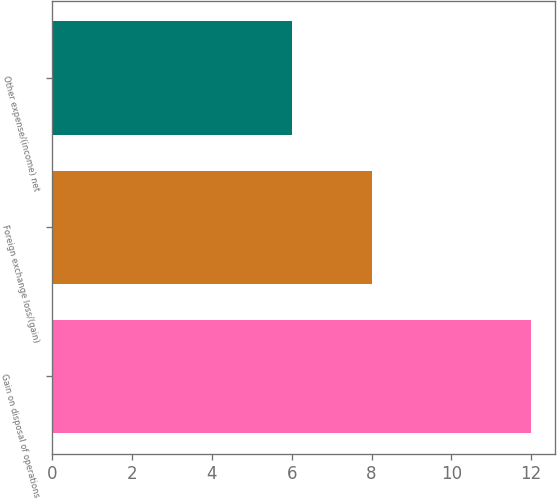Convert chart. <chart><loc_0><loc_0><loc_500><loc_500><bar_chart><fcel>Gain on disposal of operations<fcel>Foreign exchange loss/(gain)<fcel>Other expense/(income) net<nl><fcel>12<fcel>8<fcel>6<nl></chart> 